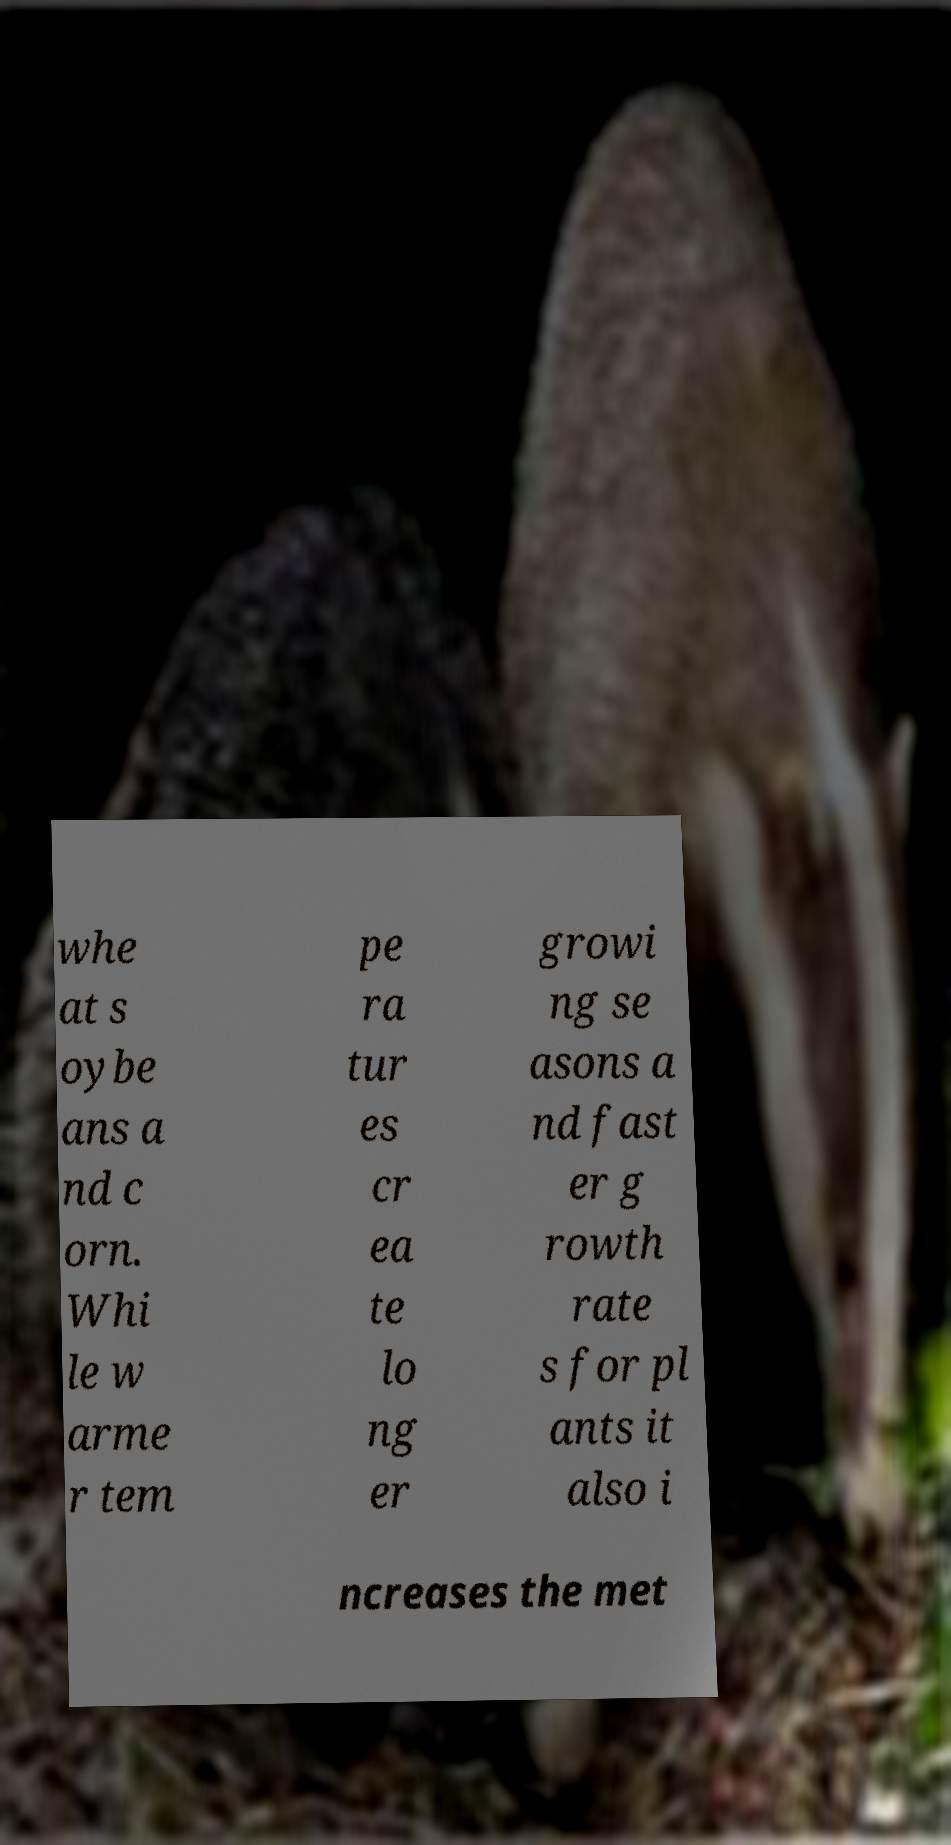What messages or text are displayed in this image? I need them in a readable, typed format. whe at s oybe ans a nd c orn. Whi le w arme r tem pe ra tur es cr ea te lo ng er growi ng se asons a nd fast er g rowth rate s for pl ants it also i ncreases the met 